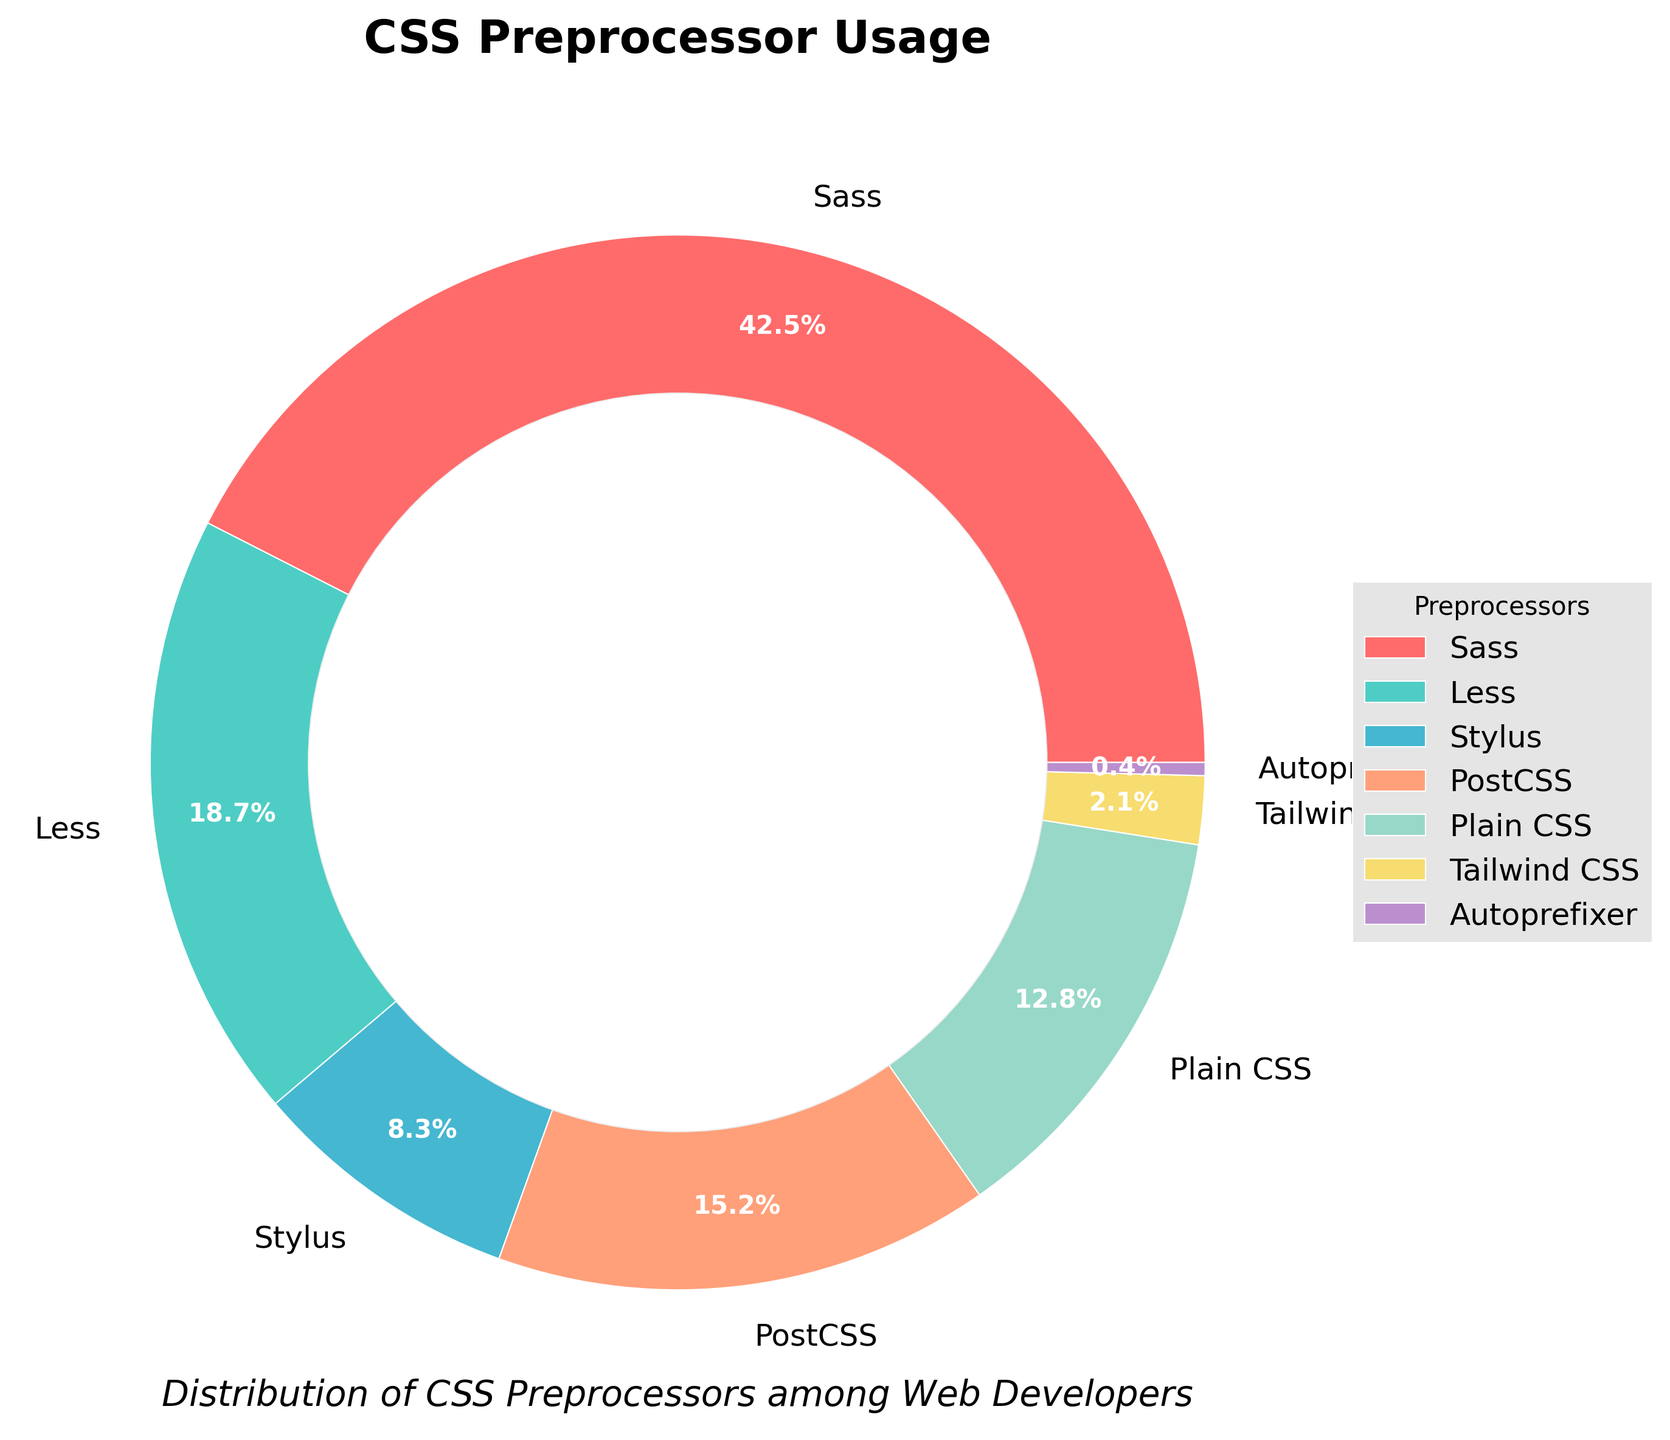What CSS preprocessor is the most used? To determine the most used CSS preprocessor, look for the largest slice in the pie chart. The slice labeled "Sass" has the largest area, so Sass is the most used CSS preprocessor.
Answer: Sass Which CSS preprocessor has the smallest usage percentage? Identify the smallest slice in the pie chart, which corresponds to the least used preprocessor. The slice labeled "Autoprefixer" is the smallest, indicating it's the least used.
Answer: Autoprefixer What is the combined usage percentage of Less and PostCSS? To find the combined usage, add the percentages for Less and PostCSS: 18.7% + 15.2% = 33.9%.
Answer: 33.9% Between Stylus and Plain CSS, which preprocessor has a higher usage percentage? Compare the slices labeled "Stylus" and "Plain CSS." The slice labeled "Plain CSS" is larger, meaning Plain CSS has a higher usage percentage than Stylus.
Answer: Plain CSS How much more popular is Sass compared to Tailwind CSS? Subtract the percentage of Tailwind CSS from Sass: 42.5% - 2.1% = 40.4%. Sass is 40.4% more popular than Tailwind CSS.
Answer: 40.4% List the preprocessors in descending order of their usage percentages. To list the preprocessors in descending order, arrange them from the largest to the smallest slice: Sass, Less, PostCSS, Plain CSS, Stylus, Tailwind CSS, Autoprefixer.
Answer: Sass, Less, PostCSS, Plain CSS, Stylus, Tailwind CSS, Autoprefixer What is the average usage percentage of Tailwind CSS, Autoprefixer, and Stylus? Find the average by adding their percentages and dividing by the count: (2.1% + 0.4% + 8.3%) / 3 ≈ 3.6%.
Answer: 3.6% Which color represents Plain CSS, and what is its usage percentage? Identify the slice labeled "Plain CSS," which is colored yellow. The usage percentage for Plain CSS is given in the label next to the yellow slice: 12.8%.
Answer: Yellow, 12.8% Does the combined usage percentage of Tailwind CSS and Autoprefixer exceed 3%? Add the percentages for Tailwind CSS and Autoprefixer and compare to 3%: 2.1% + 0.4% < 3%, so their combined usage does not exceed 3%.
Answer: No Which preprocessors have usage percentages above 15%? Look for the preprocessors with slices representing more than 15%: these are Sass (42.5%) and PostCSS (15.2%).
Answer: Sass, PostCSS 